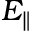Convert formula to latex. <formula><loc_0><loc_0><loc_500><loc_500>E _ { \| }</formula> 